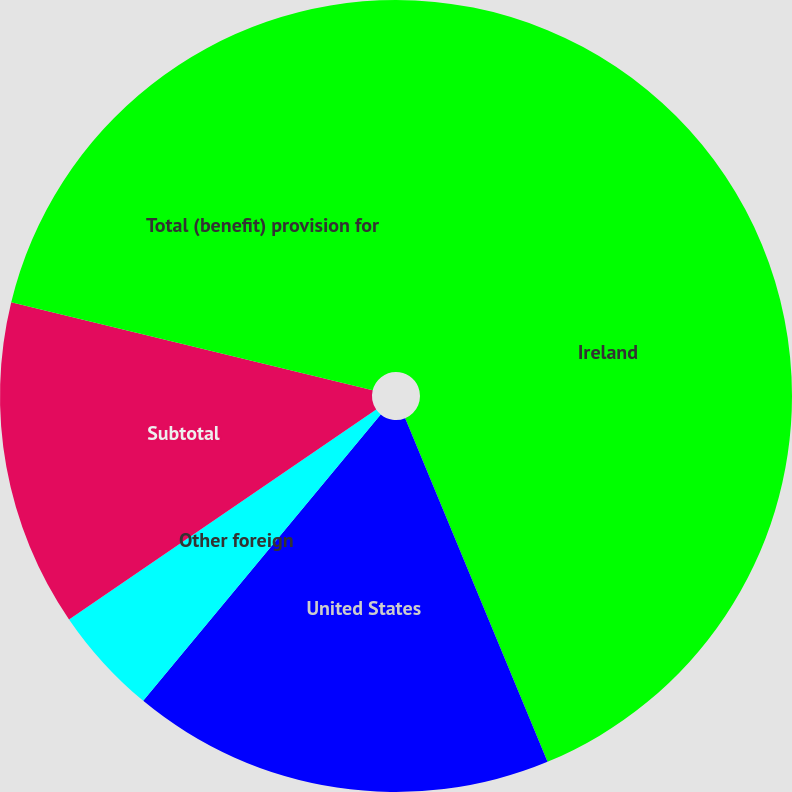<chart> <loc_0><loc_0><loc_500><loc_500><pie_chart><fcel>Ireland<fcel>United States<fcel>Other foreign<fcel>Subtotal<fcel>Total (benefit) provision for<nl><fcel>43.75%<fcel>17.27%<fcel>4.44%<fcel>13.34%<fcel>21.2%<nl></chart> 